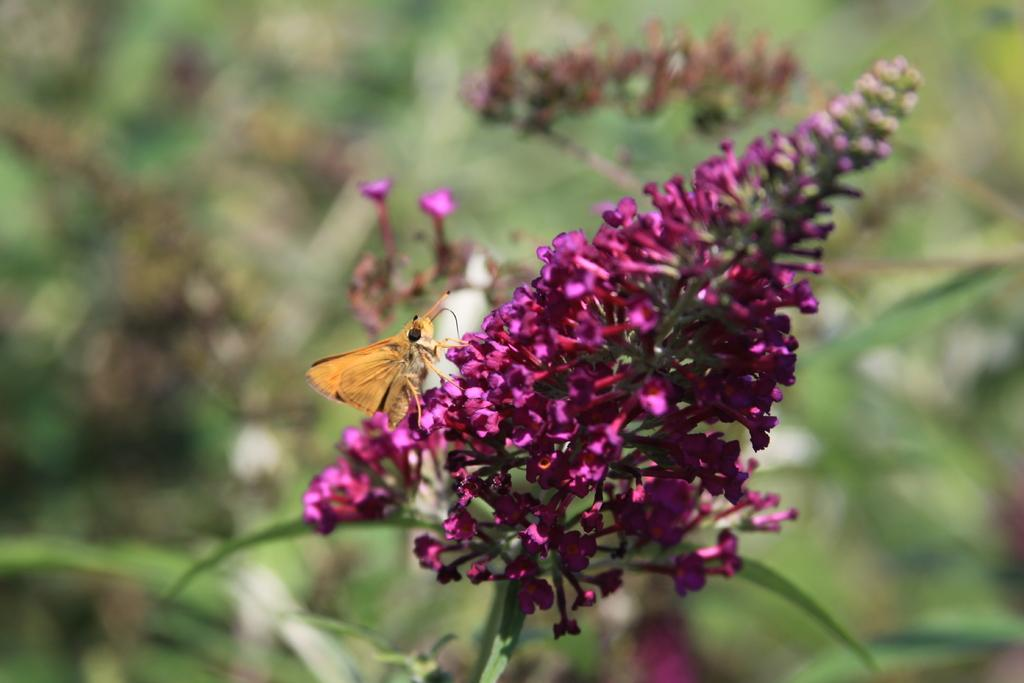What type of living organism can be seen on the plant in the image? There is an insect on the plant in the image. What feature of the plant is visible in the image? The plant has a flower. Can you see a kitten performing magic tricks with the insect on the plant? There is no kitten or magic tricks present in the image; it features a plant with a flower and an insect. 